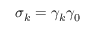<formula> <loc_0><loc_0><loc_500><loc_500>\sigma _ { k } = \gamma _ { k } \gamma _ { 0 }</formula> 